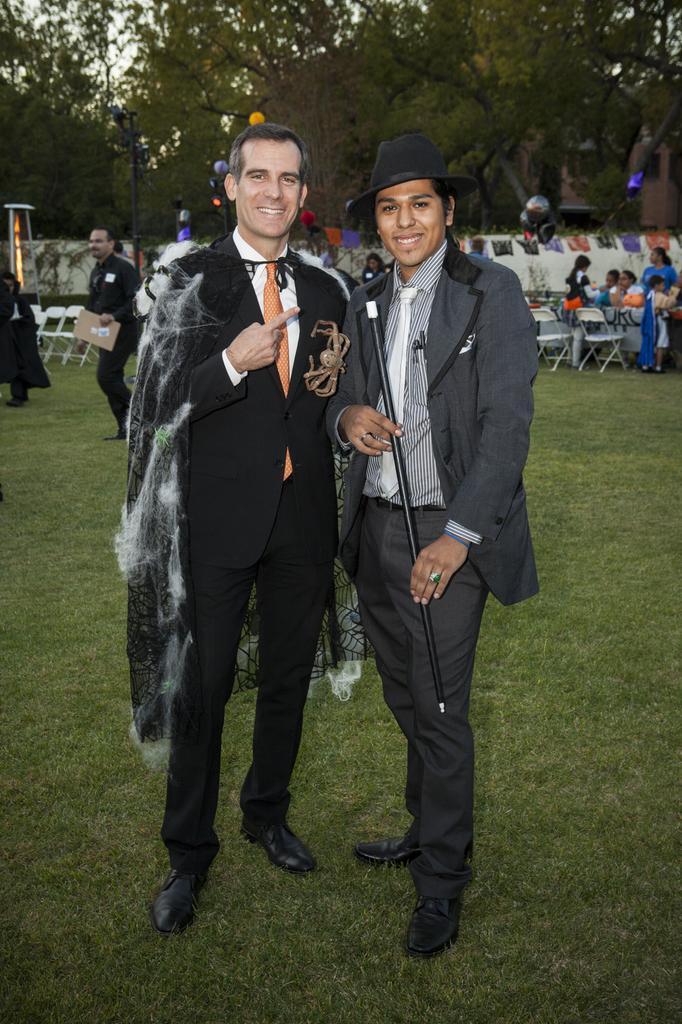Can you describe this image briefly? In the center of the image we can see two persons are standing and they are smiling, which we can see on their faces and they are in different costumes. And the right side person is holding the stick and he is wearing a cap. In the background, we can see trees, grass, banners, chairs, one table, one stool, few people are standing, few people are holding some objects and a few other objects. 